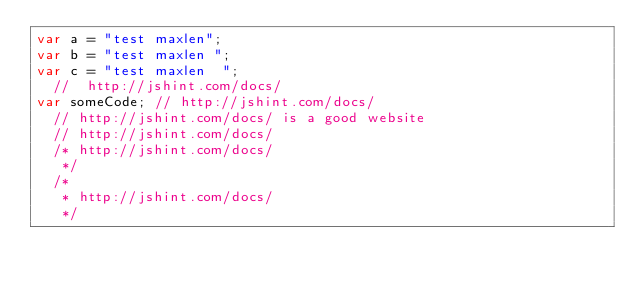Convert code to text. <code><loc_0><loc_0><loc_500><loc_500><_JavaScript_>var a = "test maxlen";
var b = "test maxlen ";
var c = "test maxlen  ";
  //  http://jshint.com/docs/
var someCode; // http://jshint.com/docs/
  // http://jshint.com/docs/ is a good website
  // http://jshint.com/docs/
  /* http://jshint.com/docs/
   */
  /*
   * http://jshint.com/docs/
   */
</code> 